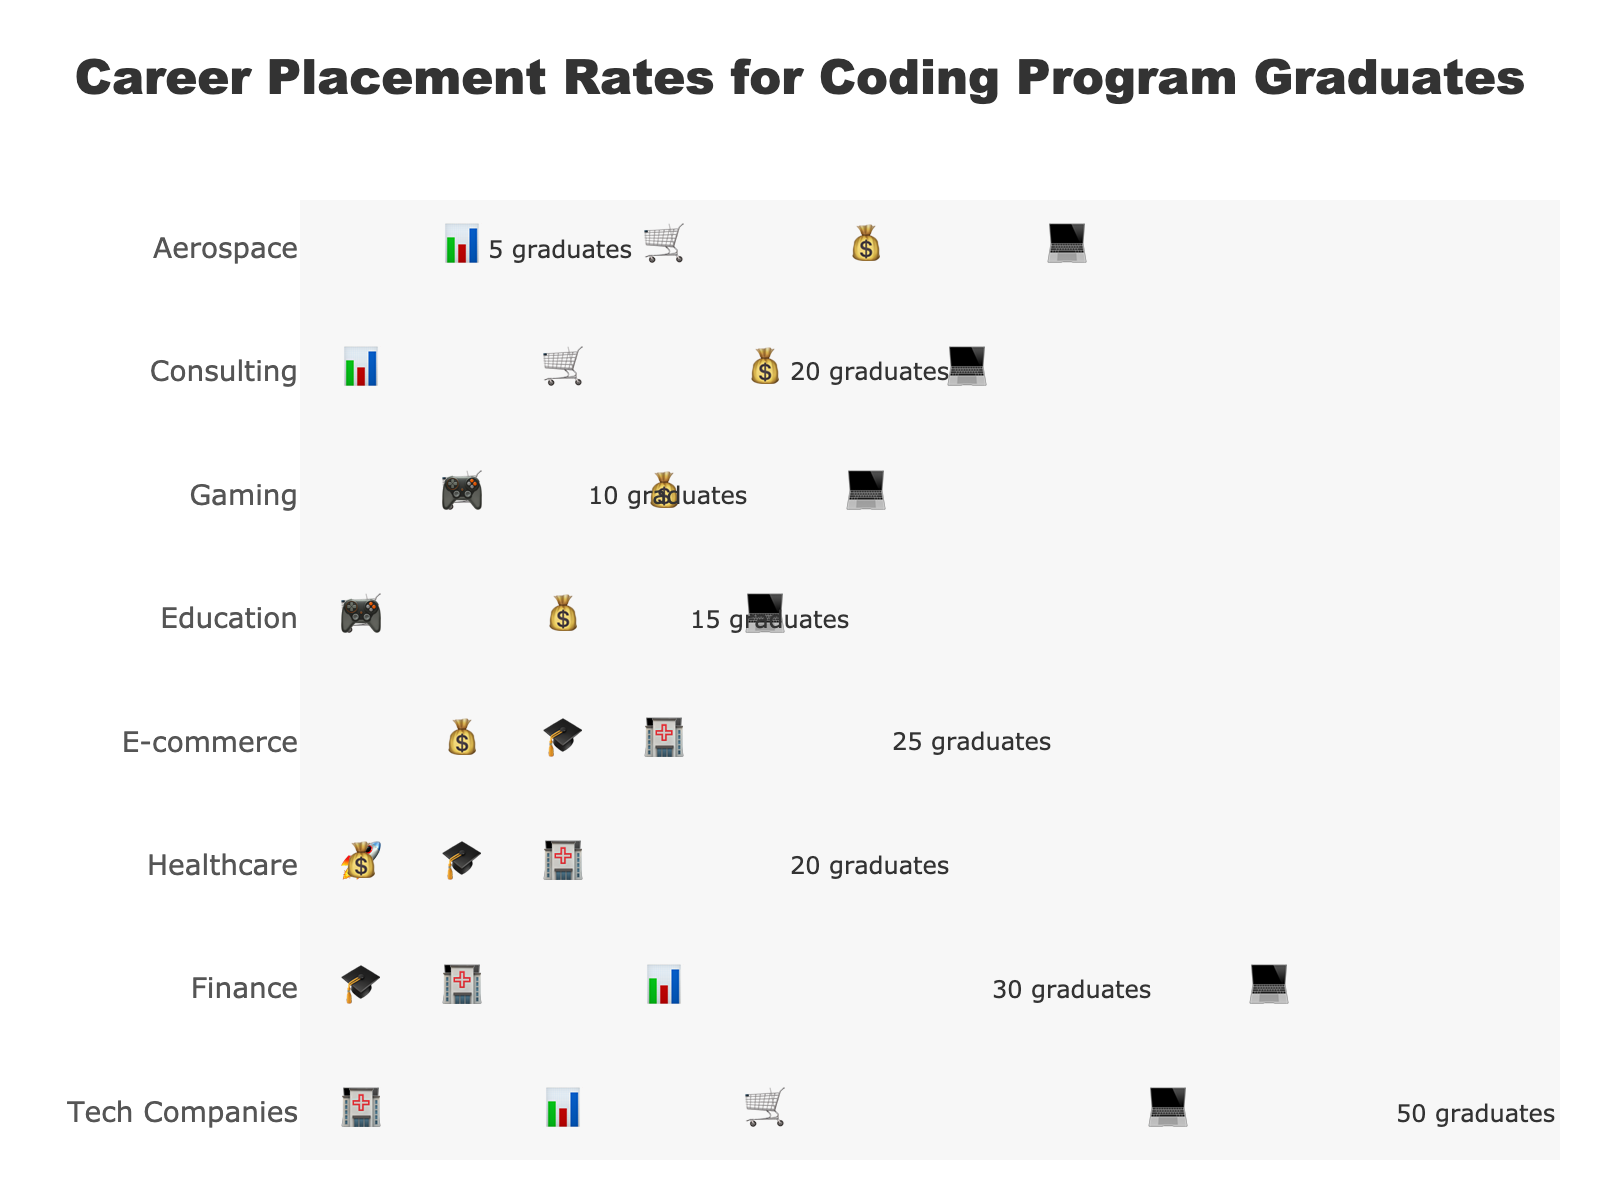What is the title of the plot? The title is usually located at the top center of the figure. The text in large font indicates the title of the plot.
Answer: Career Placement Rates for Coding Program Graduates Which industry sector has the most placed graduates? By observing the number of icons for each industry, we can see that Tech Companies has the most icons, indicating the highest number of placed graduates.
Answer: Tech Companies How many graduates were placed in the Healthcare industry? The annotation near the Healthcare industry illustrates the number of placed graduates.
Answer: 20 Which industry sectors have an equal number of placed graduates? By visually comparing the number of icons, we see that Healthcare and Consulting have the same number of graduates placed.
Answer: Healthcare and Consulting What is the total number of graduates placed across all industries? Sum up the numbers in the annotation text for each industry: 50 (Tech Companies) + 30 (Finance) + 20 (Healthcare) + 25 (E-commerce) + 15 (Education) + 10 (Gaming) + 20 (Consulting) + 5 (Aerospace) = 175.
Answer: 175 How many more graduates were placed in Tech Companies than in Gaming? Subtract the number of placed graduates in Gaming (10) from Tech Companies (50): 50 - 10.
Answer: 40 Which industry sector has the fewest placed graduates? The industry with the least number of icons is Aerospace, indicating the fewest graduates placed.
Answer: Aerospace What is the average number of graduates placed per industry sector? Divide the total number of graduates placed (175) by the number of industry sectors (8): 175 / 8.
Answer: 21.875 If you look at Healthcare and Consulting together, how many graduates were placed there in total? Add the number of placed graduates in Healthcare (20) and Consulting (20): 20 + 20.
Answer: 40 Which industry is depicted at the highest point (topmost) on the y-axis? The y-axis shows industry names, and the topmost name is Tech Companies.
Answer: Tech Companies 